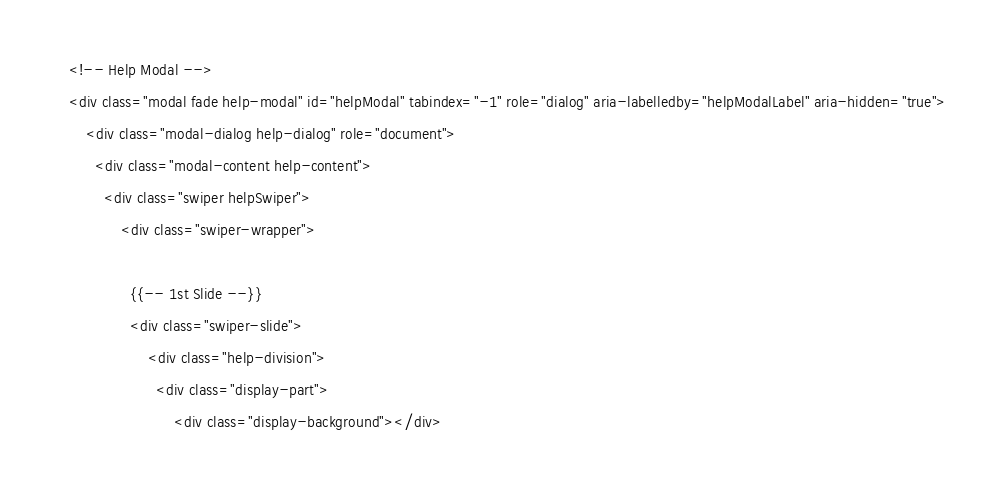<code> <loc_0><loc_0><loc_500><loc_500><_PHP_>    <!-- Help Modal -->
    <div class="modal fade help-modal" id="helpModal" tabindex="-1" role="dialog" aria-labelledby="helpModalLabel" aria-hidden="true">
        <div class="modal-dialog help-dialog" role="document">
          <div class="modal-content help-content">
            <div class="swiper helpSwiper">
                <div class="swiper-wrapper">

                  {{-- 1st Slide --}}
                  <div class="swiper-slide">
                      <div class="help-division">
                        <div class="display-part">
                            <div class="display-background"></div></code> 